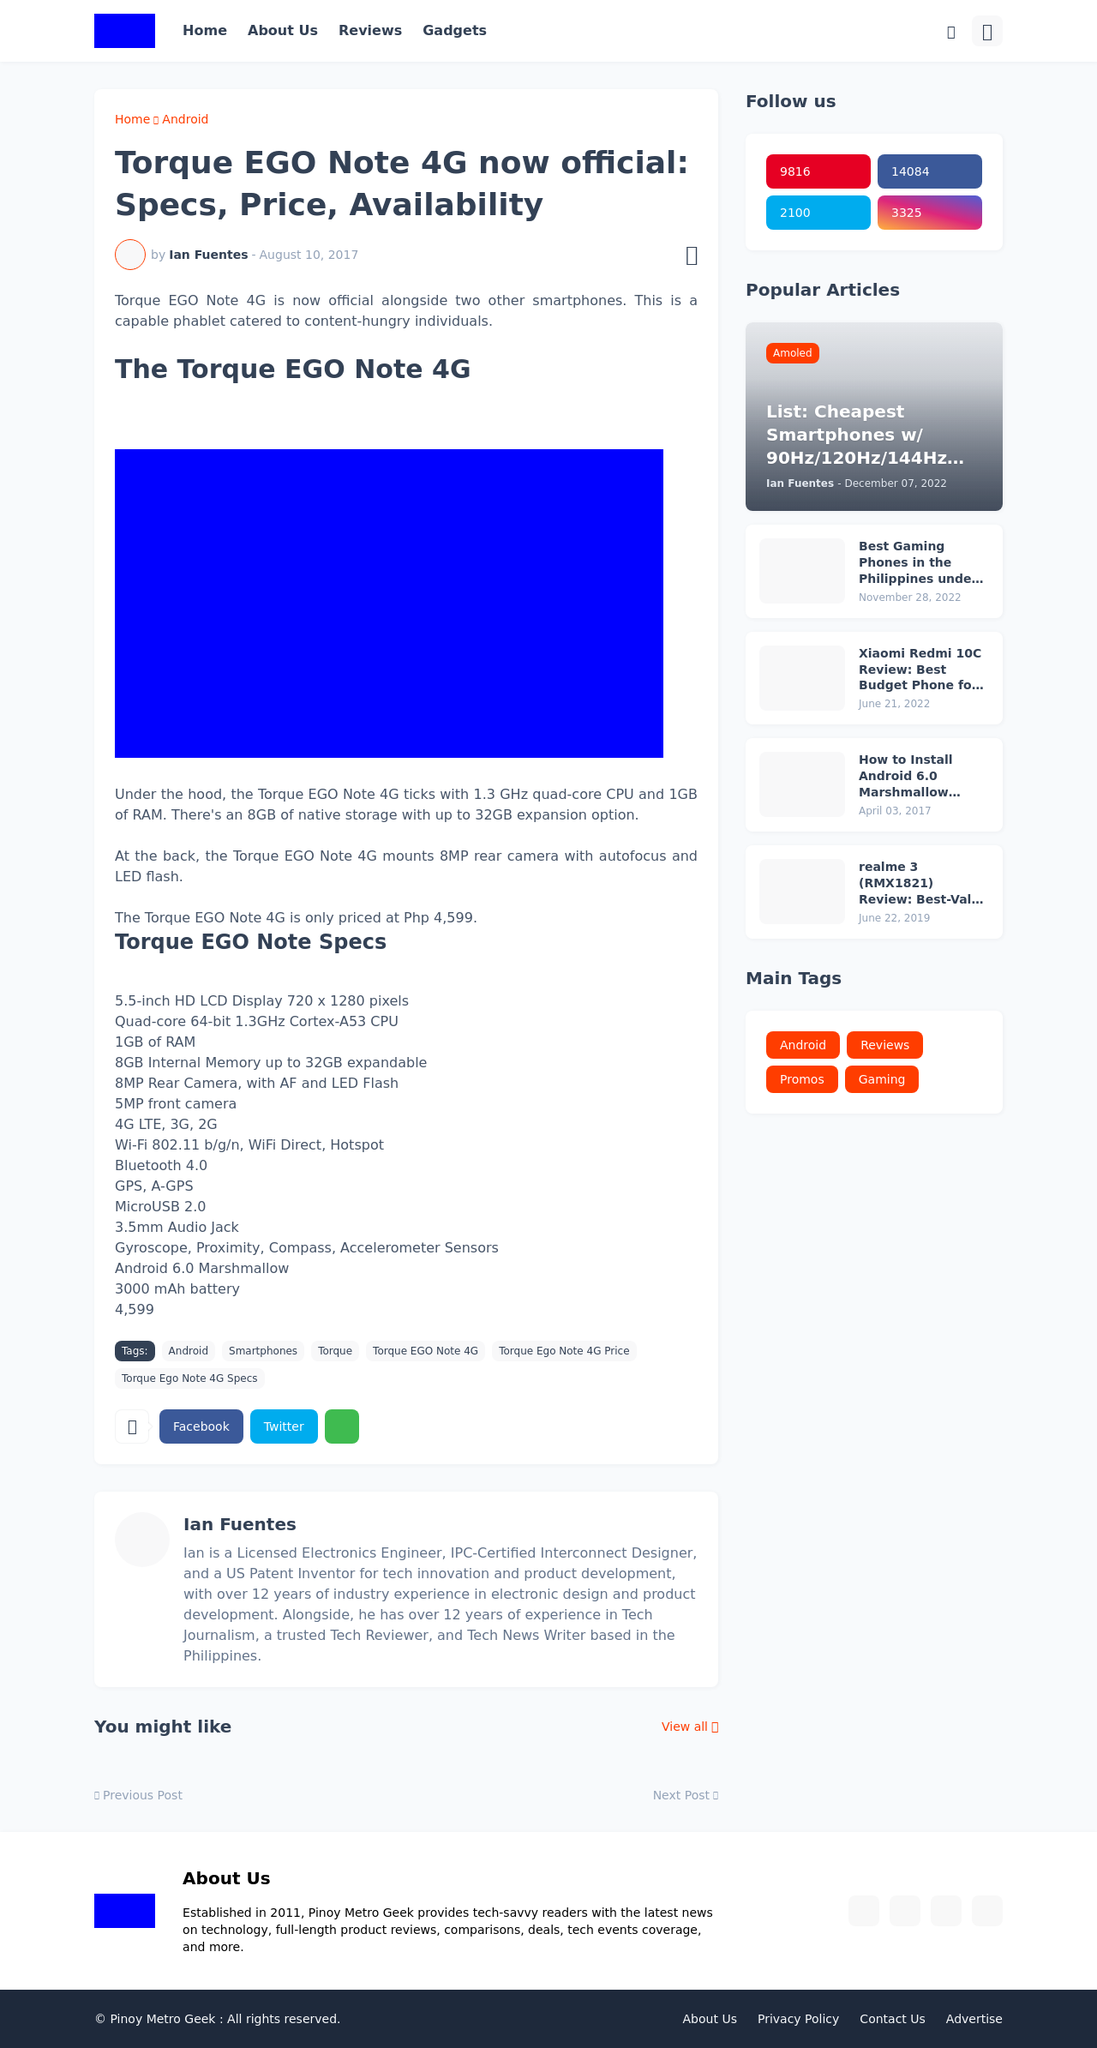What's the procedure for constructing this website from scratch with HTML? To construct a website like this from scratch using HTML and other web technologies, you would start by defining the structure with HTML to layout the various sections such as the header, main content area, sidebar, and footer. CSS would be used for styling to achieve the visual design, ensuring it is responsive and visually appealing. JavaScript might be added for interactive elements. Key functionalities would include creating navigation links, displaying posts dynamically, and integrating social media links as seen on the website. 